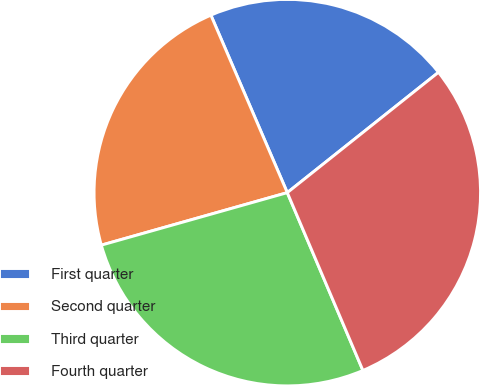<chart> <loc_0><loc_0><loc_500><loc_500><pie_chart><fcel>First quarter<fcel>Second quarter<fcel>Third quarter<fcel>Fourth quarter<nl><fcel>20.77%<fcel>22.91%<fcel>27.02%<fcel>29.3%<nl></chart> 